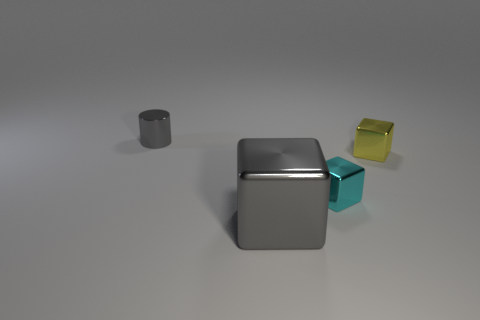Is there a tiny metal block behind the metallic thing that is left of the gray object that is in front of the shiny cylinder?
Provide a short and direct response. No. Is the number of yellow metal objects that are to the left of the tiny gray metal cylinder less than the number of tiny cubes?
Offer a terse response. Yes. What number of other things are there of the same shape as the tiny gray thing?
Offer a very short reply. 0. What number of objects are either small shiny objects right of the small gray object or objects left of the small cyan cube?
Keep it short and to the point. 4. What is the size of the block that is in front of the yellow object and behind the gray metal block?
Your answer should be compact. Small. Do the object right of the cyan object and the big object have the same shape?
Ensure brevity in your answer.  Yes. How big is the gray object that is behind the gray metallic thing in front of the thing that is behind the yellow shiny cube?
Ensure brevity in your answer.  Small. There is another thing that is the same color as the large thing; what is its size?
Your answer should be compact. Small. What number of things are either cylinders or yellow objects?
Your response must be concise. 2. The tiny metallic thing that is behind the cyan thing and to the left of the yellow metal object has what shape?
Your response must be concise. Cylinder. 